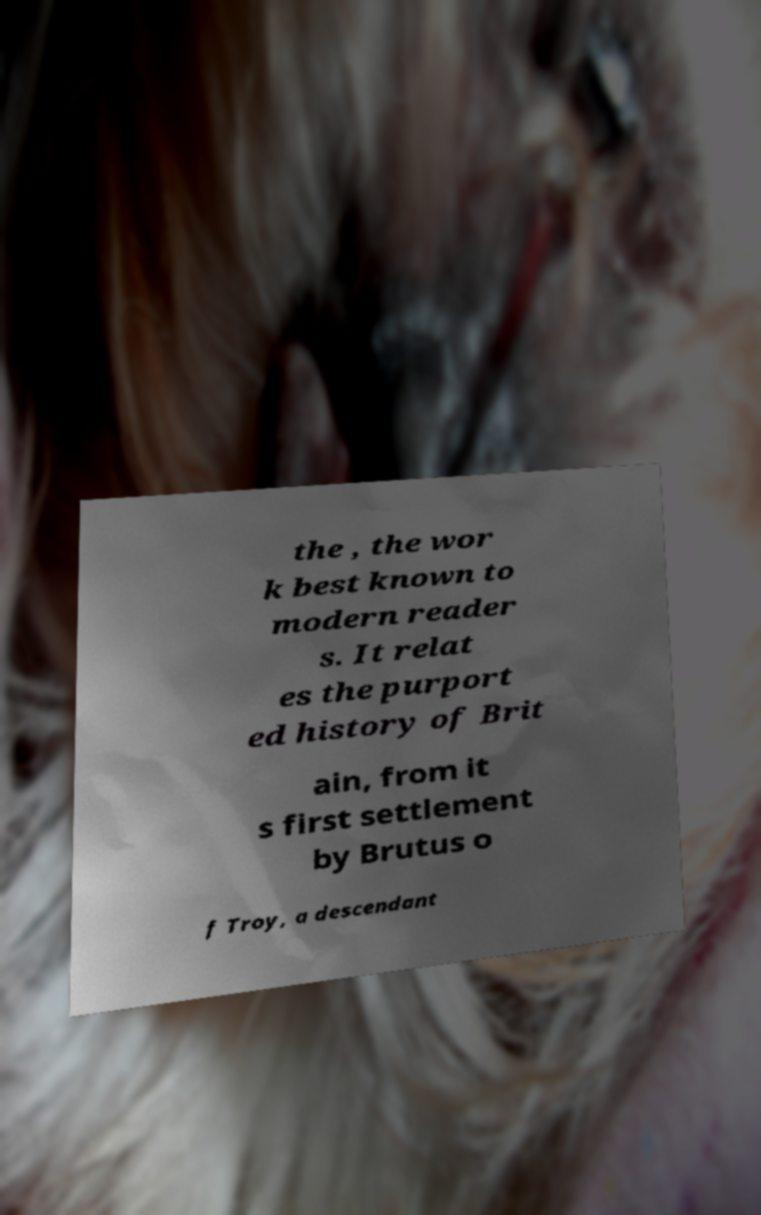Could you extract and type out the text from this image? the , the wor k best known to modern reader s. It relat es the purport ed history of Brit ain, from it s first settlement by Brutus o f Troy, a descendant 